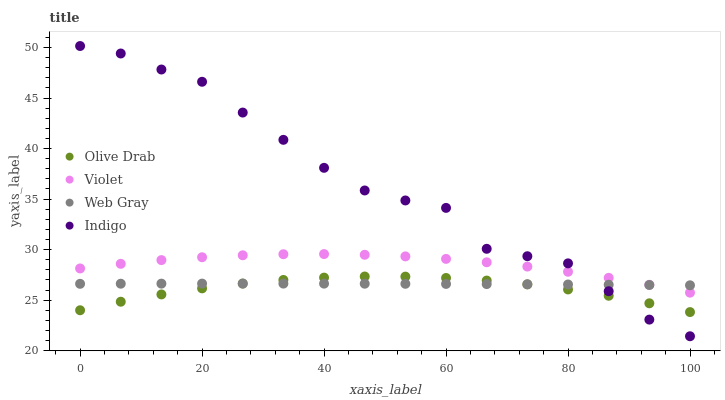Does Olive Drab have the minimum area under the curve?
Answer yes or no. Yes. Does Indigo have the maximum area under the curve?
Answer yes or no. Yes. Does Indigo have the minimum area under the curve?
Answer yes or no. No. Does Olive Drab have the maximum area under the curve?
Answer yes or no. No. Is Web Gray the smoothest?
Answer yes or no. Yes. Is Indigo the roughest?
Answer yes or no. Yes. Is Olive Drab the smoothest?
Answer yes or no. No. Is Olive Drab the roughest?
Answer yes or no. No. Does Indigo have the lowest value?
Answer yes or no. Yes. Does Olive Drab have the lowest value?
Answer yes or no. No. Does Indigo have the highest value?
Answer yes or no. Yes. Does Olive Drab have the highest value?
Answer yes or no. No. Is Olive Drab less than Violet?
Answer yes or no. Yes. Is Violet greater than Olive Drab?
Answer yes or no. Yes. Does Violet intersect Web Gray?
Answer yes or no. Yes. Is Violet less than Web Gray?
Answer yes or no. No. Is Violet greater than Web Gray?
Answer yes or no. No. Does Olive Drab intersect Violet?
Answer yes or no. No. 